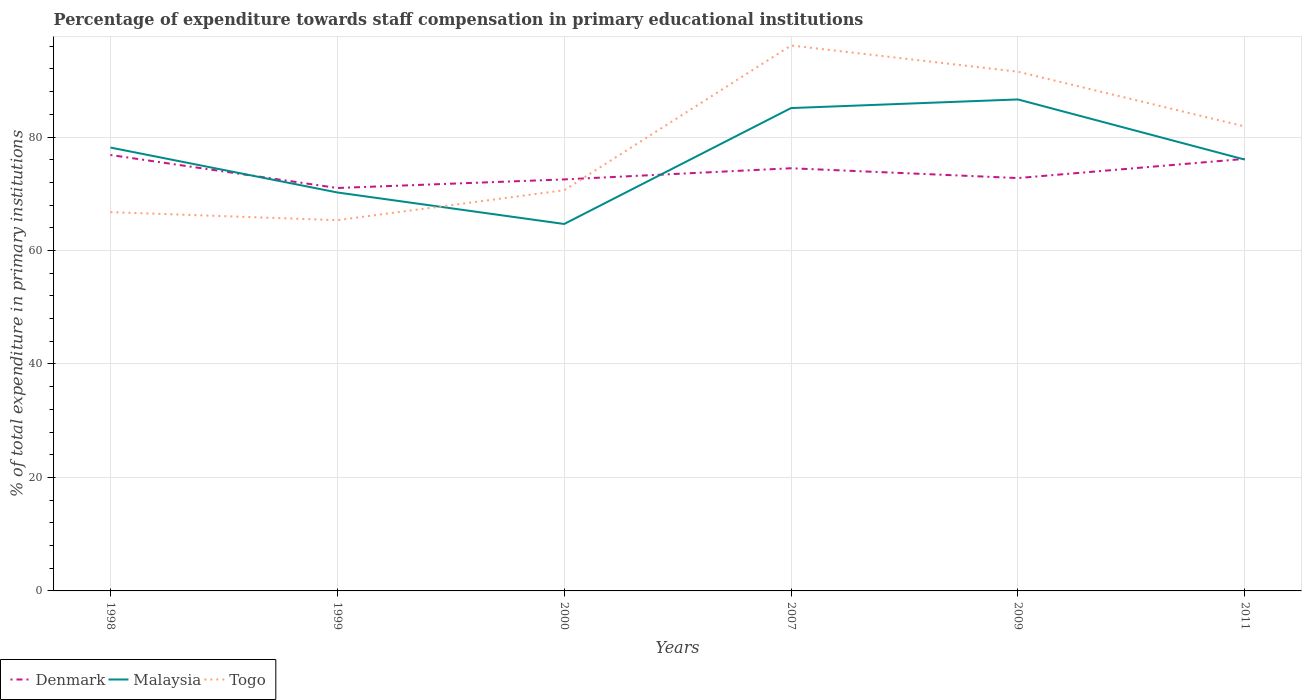How many different coloured lines are there?
Offer a very short reply. 3. Does the line corresponding to Denmark intersect with the line corresponding to Malaysia?
Make the answer very short. Yes. Is the number of lines equal to the number of legend labels?
Your answer should be very brief. Yes. Across all years, what is the maximum percentage of expenditure towards staff compensation in Denmark?
Offer a terse response. 71.01. In which year was the percentage of expenditure towards staff compensation in Denmark maximum?
Offer a very short reply. 1999. What is the total percentage of expenditure towards staff compensation in Togo in the graph?
Make the answer very short. 9.64. What is the difference between the highest and the second highest percentage of expenditure towards staff compensation in Malaysia?
Ensure brevity in your answer.  21.95. What is the difference between the highest and the lowest percentage of expenditure towards staff compensation in Denmark?
Provide a short and direct response. 3. Is the percentage of expenditure towards staff compensation in Togo strictly greater than the percentage of expenditure towards staff compensation in Denmark over the years?
Provide a short and direct response. No. What is the difference between two consecutive major ticks on the Y-axis?
Provide a succinct answer. 20. Does the graph contain any zero values?
Provide a short and direct response. No. Where does the legend appear in the graph?
Give a very brief answer. Bottom left. How are the legend labels stacked?
Your answer should be compact. Horizontal. What is the title of the graph?
Keep it short and to the point. Percentage of expenditure towards staff compensation in primary educational institutions. Does "Timor-Leste" appear as one of the legend labels in the graph?
Offer a terse response. No. What is the label or title of the X-axis?
Your answer should be compact. Years. What is the label or title of the Y-axis?
Ensure brevity in your answer.  % of total expenditure in primary institutions. What is the % of total expenditure in primary institutions in Denmark in 1998?
Your response must be concise. 76.83. What is the % of total expenditure in primary institutions of Malaysia in 1998?
Ensure brevity in your answer.  78.14. What is the % of total expenditure in primary institutions of Togo in 1998?
Provide a short and direct response. 66.76. What is the % of total expenditure in primary institutions of Denmark in 1999?
Provide a short and direct response. 71.01. What is the % of total expenditure in primary institutions in Malaysia in 1999?
Offer a very short reply. 70.23. What is the % of total expenditure in primary institutions in Togo in 1999?
Provide a succinct answer. 65.34. What is the % of total expenditure in primary institutions of Denmark in 2000?
Give a very brief answer. 72.53. What is the % of total expenditure in primary institutions of Malaysia in 2000?
Your answer should be very brief. 64.67. What is the % of total expenditure in primary institutions in Togo in 2000?
Give a very brief answer. 70.62. What is the % of total expenditure in primary institutions of Denmark in 2007?
Make the answer very short. 74.5. What is the % of total expenditure in primary institutions in Malaysia in 2007?
Your response must be concise. 85.1. What is the % of total expenditure in primary institutions of Togo in 2007?
Provide a short and direct response. 96.13. What is the % of total expenditure in primary institutions in Denmark in 2009?
Ensure brevity in your answer.  72.77. What is the % of total expenditure in primary institutions of Malaysia in 2009?
Keep it short and to the point. 86.62. What is the % of total expenditure in primary institutions of Togo in 2009?
Give a very brief answer. 91.51. What is the % of total expenditure in primary institutions in Denmark in 2011?
Give a very brief answer. 76.15. What is the % of total expenditure in primary institutions of Malaysia in 2011?
Keep it short and to the point. 76.02. What is the % of total expenditure in primary institutions of Togo in 2011?
Your answer should be very brief. 81.87. Across all years, what is the maximum % of total expenditure in primary institutions of Denmark?
Offer a very short reply. 76.83. Across all years, what is the maximum % of total expenditure in primary institutions of Malaysia?
Your response must be concise. 86.62. Across all years, what is the maximum % of total expenditure in primary institutions of Togo?
Provide a short and direct response. 96.13. Across all years, what is the minimum % of total expenditure in primary institutions in Denmark?
Offer a terse response. 71.01. Across all years, what is the minimum % of total expenditure in primary institutions in Malaysia?
Provide a succinct answer. 64.67. Across all years, what is the minimum % of total expenditure in primary institutions of Togo?
Provide a short and direct response. 65.34. What is the total % of total expenditure in primary institutions of Denmark in the graph?
Your response must be concise. 443.78. What is the total % of total expenditure in primary institutions in Malaysia in the graph?
Offer a very short reply. 460.79. What is the total % of total expenditure in primary institutions in Togo in the graph?
Your response must be concise. 472.23. What is the difference between the % of total expenditure in primary institutions in Denmark in 1998 and that in 1999?
Offer a very short reply. 5.82. What is the difference between the % of total expenditure in primary institutions of Malaysia in 1998 and that in 1999?
Ensure brevity in your answer.  7.92. What is the difference between the % of total expenditure in primary institutions of Togo in 1998 and that in 1999?
Provide a short and direct response. 1.42. What is the difference between the % of total expenditure in primary institutions in Denmark in 1998 and that in 2000?
Provide a succinct answer. 4.31. What is the difference between the % of total expenditure in primary institutions in Malaysia in 1998 and that in 2000?
Give a very brief answer. 13.47. What is the difference between the % of total expenditure in primary institutions of Togo in 1998 and that in 2000?
Offer a very short reply. -3.86. What is the difference between the % of total expenditure in primary institutions in Denmark in 1998 and that in 2007?
Your response must be concise. 2.34. What is the difference between the % of total expenditure in primary institutions in Malaysia in 1998 and that in 2007?
Your response must be concise. -6.96. What is the difference between the % of total expenditure in primary institutions of Togo in 1998 and that in 2007?
Give a very brief answer. -29.37. What is the difference between the % of total expenditure in primary institutions in Denmark in 1998 and that in 2009?
Your response must be concise. 4.07. What is the difference between the % of total expenditure in primary institutions in Malaysia in 1998 and that in 2009?
Provide a short and direct response. -8.48. What is the difference between the % of total expenditure in primary institutions in Togo in 1998 and that in 2009?
Provide a succinct answer. -24.75. What is the difference between the % of total expenditure in primary institutions of Denmark in 1998 and that in 2011?
Keep it short and to the point. 0.69. What is the difference between the % of total expenditure in primary institutions in Malaysia in 1998 and that in 2011?
Provide a short and direct response. 2.12. What is the difference between the % of total expenditure in primary institutions in Togo in 1998 and that in 2011?
Your answer should be compact. -15.1. What is the difference between the % of total expenditure in primary institutions in Denmark in 1999 and that in 2000?
Make the answer very short. -1.51. What is the difference between the % of total expenditure in primary institutions in Malaysia in 1999 and that in 2000?
Give a very brief answer. 5.56. What is the difference between the % of total expenditure in primary institutions in Togo in 1999 and that in 2000?
Offer a terse response. -5.28. What is the difference between the % of total expenditure in primary institutions of Denmark in 1999 and that in 2007?
Provide a short and direct response. -3.48. What is the difference between the % of total expenditure in primary institutions in Malaysia in 1999 and that in 2007?
Keep it short and to the point. -14.87. What is the difference between the % of total expenditure in primary institutions in Togo in 1999 and that in 2007?
Make the answer very short. -30.78. What is the difference between the % of total expenditure in primary institutions in Denmark in 1999 and that in 2009?
Provide a succinct answer. -1.75. What is the difference between the % of total expenditure in primary institutions of Malaysia in 1999 and that in 2009?
Keep it short and to the point. -16.4. What is the difference between the % of total expenditure in primary institutions in Togo in 1999 and that in 2009?
Your answer should be compact. -26.17. What is the difference between the % of total expenditure in primary institutions of Denmark in 1999 and that in 2011?
Your answer should be compact. -5.13. What is the difference between the % of total expenditure in primary institutions of Malaysia in 1999 and that in 2011?
Offer a very short reply. -5.79. What is the difference between the % of total expenditure in primary institutions of Togo in 1999 and that in 2011?
Give a very brief answer. -16.52. What is the difference between the % of total expenditure in primary institutions of Denmark in 2000 and that in 2007?
Your answer should be compact. -1.97. What is the difference between the % of total expenditure in primary institutions in Malaysia in 2000 and that in 2007?
Ensure brevity in your answer.  -20.43. What is the difference between the % of total expenditure in primary institutions of Togo in 2000 and that in 2007?
Provide a succinct answer. -25.51. What is the difference between the % of total expenditure in primary institutions in Denmark in 2000 and that in 2009?
Your response must be concise. -0.24. What is the difference between the % of total expenditure in primary institutions in Malaysia in 2000 and that in 2009?
Your answer should be very brief. -21.95. What is the difference between the % of total expenditure in primary institutions of Togo in 2000 and that in 2009?
Give a very brief answer. -20.89. What is the difference between the % of total expenditure in primary institutions of Denmark in 2000 and that in 2011?
Your answer should be compact. -3.62. What is the difference between the % of total expenditure in primary institutions of Malaysia in 2000 and that in 2011?
Offer a terse response. -11.35. What is the difference between the % of total expenditure in primary institutions in Togo in 2000 and that in 2011?
Your response must be concise. -11.24. What is the difference between the % of total expenditure in primary institutions of Denmark in 2007 and that in 2009?
Keep it short and to the point. 1.73. What is the difference between the % of total expenditure in primary institutions of Malaysia in 2007 and that in 2009?
Ensure brevity in your answer.  -1.52. What is the difference between the % of total expenditure in primary institutions of Togo in 2007 and that in 2009?
Give a very brief answer. 4.62. What is the difference between the % of total expenditure in primary institutions in Denmark in 2007 and that in 2011?
Your answer should be compact. -1.65. What is the difference between the % of total expenditure in primary institutions in Malaysia in 2007 and that in 2011?
Keep it short and to the point. 9.08. What is the difference between the % of total expenditure in primary institutions of Togo in 2007 and that in 2011?
Your response must be concise. 14.26. What is the difference between the % of total expenditure in primary institutions of Denmark in 2009 and that in 2011?
Keep it short and to the point. -3.38. What is the difference between the % of total expenditure in primary institutions in Malaysia in 2009 and that in 2011?
Offer a terse response. 10.6. What is the difference between the % of total expenditure in primary institutions in Togo in 2009 and that in 2011?
Provide a succinct answer. 9.64. What is the difference between the % of total expenditure in primary institutions in Denmark in 1998 and the % of total expenditure in primary institutions in Malaysia in 1999?
Provide a short and direct response. 6.6. What is the difference between the % of total expenditure in primary institutions of Denmark in 1998 and the % of total expenditure in primary institutions of Togo in 1999?
Give a very brief answer. 11.49. What is the difference between the % of total expenditure in primary institutions in Malaysia in 1998 and the % of total expenditure in primary institutions in Togo in 1999?
Your answer should be compact. 12.8. What is the difference between the % of total expenditure in primary institutions in Denmark in 1998 and the % of total expenditure in primary institutions in Malaysia in 2000?
Give a very brief answer. 12.16. What is the difference between the % of total expenditure in primary institutions in Denmark in 1998 and the % of total expenditure in primary institutions in Togo in 2000?
Make the answer very short. 6.21. What is the difference between the % of total expenditure in primary institutions of Malaysia in 1998 and the % of total expenditure in primary institutions of Togo in 2000?
Offer a very short reply. 7.52. What is the difference between the % of total expenditure in primary institutions in Denmark in 1998 and the % of total expenditure in primary institutions in Malaysia in 2007?
Offer a terse response. -8.27. What is the difference between the % of total expenditure in primary institutions in Denmark in 1998 and the % of total expenditure in primary institutions in Togo in 2007?
Your answer should be compact. -19.3. What is the difference between the % of total expenditure in primary institutions in Malaysia in 1998 and the % of total expenditure in primary institutions in Togo in 2007?
Make the answer very short. -17.99. What is the difference between the % of total expenditure in primary institutions of Denmark in 1998 and the % of total expenditure in primary institutions of Malaysia in 2009?
Give a very brief answer. -9.79. What is the difference between the % of total expenditure in primary institutions in Denmark in 1998 and the % of total expenditure in primary institutions in Togo in 2009?
Your answer should be very brief. -14.68. What is the difference between the % of total expenditure in primary institutions in Malaysia in 1998 and the % of total expenditure in primary institutions in Togo in 2009?
Offer a very short reply. -13.37. What is the difference between the % of total expenditure in primary institutions in Denmark in 1998 and the % of total expenditure in primary institutions in Malaysia in 2011?
Provide a short and direct response. 0.81. What is the difference between the % of total expenditure in primary institutions of Denmark in 1998 and the % of total expenditure in primary institutions of Togo in 2011?
Offer a terse response. -5.03. What is the difference between the % of total expenditure in primary institutions in Malaysia in 1998 and the % of total expenditure in primary institutions in Togo in 2011?
Ensure brevity in your answer.  -3.72. What is the difference between the % of total expenditure in primary institutions in Denmark in 1999 and the % of total expenditure in primary institutions in Malaysia in 2000?
Offer a terse response. 6.34. What is the difference between the % of total expenditure in primary institutions of Denmark in 1999 and the % of total expenditure in primary institutions of Togo in 2000?
Ensure brevity in your answer.  0.39. What is the difference between the % of total expenditure in primary institutions in Malaysia in 1999 and the % of total expenditure in primary institutions in Togo in 2000?
Provide a short and direct response. -0.39. What is the difference between the % of total expenditure in primary institutions in Denmark in 1999 and the % of total expenditure in primary institutions in Malaysia in 2007?
Ensure brevity in your answer.  -14.09. What is the difference between the % of total expenditure in primary institutions of Denmark in 1999 and the % of total expenditure in primary institutions of Togo in 2007?
Offer a very short reply. -25.12. What is the difference between the % of total expenditure in primary institutions of Malaysia in 1999 and the % of total expenditure in primary institutions of Togo in 2007?
Your response must be concise. -25.9. What is the difference between the % of total expenditure in primary institutions of Denmark in 1999 and the % of total expenditure in primary institutions of Malaysia in 2009?
Make the answer very short. -15.61. What is the difference between the % of total expenditure in primary institutions in Denmark in 1999 and the % of total expenditure in primary institutions in Togo in 2009?
Keep it short and to the point. -20.5. What is the difference between the % of total expenditure in primary institutions of Malaysia in 1999 and the % of total expenditure in primary institutions of Togo in 2009?
Give a very brief answer. -21.28. What is the difference between the % of total expenditure in primary institutions of Denmark in 1999 and the % of total expenditure in primary institutions of Malaysia in 2011?
Your answer should be compact. -5.01. What is the difference between the % of total expenditure in primary institutions in Denmark in 1999 and the % of total expenditure in primary institutions in Togo in 2011?
Keep it short and to the point. -10.85. What is the difference between the % of total expenditure in primary institutions of Malaysia in 1999 and the % of total expenditure in primary institutions of Togo in 2011?
Your answer should be very brief. -11.64. What is the difference between the % of total expenditure in primary institutions of Denmark in 2000 and the % of total expenditure in primary institutions of Malaysia in 2007?
Your response must be concise. -12.57. What is the difference between the % of total expenditure in primary institutions in Denmark in 2000 and the % of total expenditure in primary institutions in Togo in 2007?
Make the answer very short. -23.6. What is the difference between the % of total expenditure in primary institutions in Malaysia in 2000 and the % of total expenditure in primary institutions in Togo in 2007?
Your answer should be compact. -31.46. What is the difference between the % of total expenditure in primary institutions of Denmark in 2000 and the % of total expenditure in primary institutions of Malaysia in 2009?
Make the answer very short. -14.1. What is the difference between the % of total expenditure in primary institutions in Denmark in 2000 and the % of total expenditure in primary institutions in Togo in 2009?
Offer a terse response. -18.98. What is the difference between the % of total expenditure in primary institutions in Malaysia in 2000 and the % of total expenditure in primary institutions in Togo in 2009?
Make the answer very short. -26.84. What is the difference between the % of total expenditure in primary institutions of Denmark in 2000 and the % of total expenditure in primary institutions of Malaysia in 2011?
Ensure brevity in your answer.  -3.49. What is the difference between the % of total expenditure in primary institutions of Denmark in 2000 and the % of total expenditure in primary institutions of Togo in 2011?
Your answer should be very brief. -9.34. What is the difference between the % of total expenditure in primary institutions of Malaysia in 2000 and the % of total expenditure in primary institutions of Togo in 2011?
Offer a terse response. -17.19. What is the difference between the % of total expenditure in primary institutions of Denmark in 2007 and the % of total expenditure in primary institutions of Malaysia in 2009?
Your response must be concise. -12.13. What is the difference between the % of total expenditure in primary institutions of Denmark in 2007 and the % of total expenditure in primary institutions of Togo in 2009?
Offer a terse response. -17.01. What is the difference between the % of total expenditure in primary institutions in Malaysia in 2007 and the % of total expenditure in primary institutions in Togo in 2009?
Provide a succinct answer. -6.41. What is the difference between the % of total expenditure in primary institutions of Denmark in 2007 and the % of total expenditure in primary institutions of Malaysia in 2011?
Keep it short and to the point. -1.53. What is the difference between the % of total expenditure in primary institutions in Denmark in 2007 and the % of total expenditure in primary institutions in Togo in 2011?
Make the answer very short. -7.37. What is the difference between the % of total expenditure in primary institutions in Malaysia in 2007 and the % of total expenditure in primary institutions in Togo in 2011?
Ensure brevity in your answer.  3.24. What is the difference between the % of total expenditure in primary institutions of Denmark in 2009 and the % of total expenditure in primary institutions of Malaysia in 2011?
Make the answer very short. -3.25. What is the difference between the % of total expenditure in primary institutions of Denmark in 2009 and the % of total expenditure in primary institutions of Togo in 2011?
Your response must be concise. -9.1. What is the difference between the % of total expenditure in primary institutions in Malaysia in 2009 and the % of total expenditure in primary institutions in Togo in 2011?
Keep it short and to the point. 4.76. What is the average % of total expenditure in primary institutions of Denmark per year?
Make the answer very short. 73.96. What is the average % of total expenditure in primary institutions of Malaysia per year?
Make the answer very short. 76.8. What is the average % of total expenditure in primary institutions in Togo per year?
Ensure brevity in your answer.  78.71. In the year 1998, what is the difference between the % of total expenditure in primary institutions in Denmark and % of total expenditure in primary institutions in Malaysia?
Give a very brief answer. -1.31. In the year 1998, what is the difference between the % of total expenditure in primary institutions in Denmark and % of total expenditure in primary institutions in Togo?
Keep it short and to the point. 10.07. In the year 1998, what is the difference between the % of total expenditure in primary institutions of Malaysia and % of total expenditure in primary institutions of Togo?
Offer a terse response. 11.38. In the year 1999, what is the difference between the % of total expenditure in primary institutions in Denmark and % of total expenditure in primary institutions in Malaysia?
Provide a succinct answer. 0.79. In the year 1999, what is the difference between the % of total expenditure in primary institutions of Denmark and % of total expenditure in primary institutions of Togo?
Keep it short and to the point. 5.67. In the year 1999, what is the difference between the % of total expenditure in primary institutions of Malaysia and % of total expenditure in primary institutions of Togo?
Ensure brevity in your answer.  4.88. In the year 2000, what is the difference between the % of total expenditure in primary institutions in Denmark and % of total expenditure in primary institutions in Malaysia?
Your answer should be compact. 7.85. In the year 2000, what is the difference between the % of total expenditure in primary institutions of Denmark and % of total expenditure in primary institutions of Togo?
Provide a short and direct response. 1.91. In the year 2000, what is the difference between the % of total expenditure in primary institutions in Malaysia and % of total expenditure in primary institutions in Togo?
Your response must be concise. -5.95. In the year 2007, what is the difference between the % of total expenditure in primary institutions in Denmark and % of total expenditure in primary institutions in Malaysia?
Ensure brevity in your answer.  -10.61. In the year 2007, what is the difference between the % of total expenditure in primary institutions in Denmark and % of total expenditure in primary institutions in Togo?
Your response must be concise. -21.63. In the year 2007, what is the difference between the % of total expenditure in primary institutions of Malaysia and % of total expenditure in primary institutions of Togo?
Your answer should be very brief. -11.03. In the year 2009, what is the difference between the % of total expenditure in primary institutions in Denmark and % of total expenditure in primary institutions in Malaysia?
Give a very brief answer. -13.86. In the year 2009, what is the difference between the % of total expenditure in primary institutions of Denmark and % of total expenditure in primary institutions of Togo?
Offer a terse response. -18.74. In the year 2009, what is the difference between the % of total expenditure in primary institutions in Malaysia and % of total expenditure in primary institutions in Togo?
Ensure brevity in your answer.  -4.89. In the year 2011, what is the difference between the % of total expenditure in primary institutions in Denmark and % of total expenditure in primary institutions in Malaysia?
Provide a succinct answer. 0.12. In the year 2011, what is the difference between the % of total expenditure in primary institutions in Denmark and % of total expenditure in primary institutions in Togo?
Offer a very short reply. -5.72. In the year 2011, what is the difference between the % of total expenditure in primary institutions of Malaysia and % of total expenditure in primary institutions of Togo?
Ensure brevity in your answer.  -5.84. What is the ratio of the % of total expenditure in primary institutions of Denmark in 1998 to that in 1999?
Your response must be concise. 1.08. What is the ratio of the % of total expenditure in primary institutions in Malaysia in 1998 to that in 1999?
Provide a short and direct response. 1.11. What is the ratio of the % of total expenditure in primary institutions in Togo in 1998 to that in 1999?
Your response must be concise. 1.02. What is the ratio of the % of total expenditure in primary institutions in Denmark in 1998 to that in 2000?
Provide a short and direct response. 1.06. What is the ratio of the % of total expenditure in primary institutions in Malaysia in 1998 to that in 2000?
Keep it short and to the point. 1.21. What is the ratio of the % of total expenditure in primary institutions of Togo in 1998 to that in 2000?
Provide a succinct answer. 0.95. What is the ratio of the % of total expenditure in primary institutions of Denmark in 1998 to that in 2007?
Your response must be concise. 1.03. What is the ratio of the % of total expenditure in primary institutions in Malaysia in 1998 to that in 2007?
Provide a short and direct response. 0.92. What is the ratio of the % of total expenditure in primary institutions in Togo in 1998 to that in 2007?
Make the answer very short. 0.69. What is the ratio of the % of total expenditure in primary institutions of Denmark in 1998 to that in 2009?
Offer a terse response. 1.06. What is the ratio of the % of total expenditure in primary institutions of Malaysia in 1998 to that in 2009?
Keep it short and to the point. 0.9. What is the ratio of the % of total expenditure in primary institutions in Togo in 1998 to that in 2009?
Provide a short and direct response. 0.73. What is the ratio of the % of total expenditure in primary institutions in Denmark in 1998 to that in 2011?
Offer a very short reply. 1.01. What is the ratio of the % of total expenditure in primary institutions in Malaysia in 1998 to that in 2011?
Offer a very short reply. 1.03. What is the ratio of the % of total expenditure in primary institutions in Togo in 1998 to that in 2011?
Make the answer very short. 0.82. What is the ratio of the % of total expenditure in primary institutions of Denmark in 1999 to that in 2000?
Offer a terse response. 0.98. What is the ratio of the % of total expenditure in primary institutions in Malaysia in 1999 to that in 2000?
Your answer should be very brief. 1.09. What is the ratio of the % of total expenditure in primary institutions in Togo in 1999 to that in 2000?
Provide a succinct answer. 0.93. What is the ratio of the % of total expenditure in primary institutions of Denmark in 1999 to that in 2007?
Ensure brevity in your answer.  0.95. What is the ratio of the % of total expenditure in primary institutions in Malaysia in 1999 to that in 2007?
Offer a terse response. 0.83. What is the ratio of the % of total expenditure in primary institutions in Togo in 1999 to that in 2007?
Your answer should be very brief. 0.68. What is the ratio of the % of total expenditure in primary institutions in Denmark in 1999 to that in 2009?
Keep it short and to the point. 0.98. What is the ratio of the % of total expenditure in primary institutions of Malaysia in 1999 to that in 2009?
Provide a short and direct response. 0.81. What is the ratio of the % of total expenditure in primary institutions of Togo in 1999 to that in 2009?
Your answer should be compact. 0.71. What is the ratio of the % of total expenditure in primary institutions in Denmark in 1999 to that in 2011?
Make the answer very short. 0.93. What is the ratio of the % of total expenditure in primary institutions of Malaysia in 1999 to that in 2011?
Ensure brevity in your answer.  0.92. What is the ratio of the % of total expenditure in primary institutions in Togo in 1999 to that in 2011?
Keep it short and to the point. 0.8. What is the ratio of the % of total expenditure in primary institutions of Denmark in 2000 to that in 2007?
Give a very brief answer. 0.97. What is the ratio of the % of total expenditure in primary institutions in Malaysia in 2000 to that in 2007?
Provide a succinct answer. 0.76. What is the ratio of the % of total expenditure in primary institutions of Togo in 2000 to that in 2007?
Offer a very short reply. 0.73. What is the ratio of the % of total expenditure in primary institutions in Denmark in 2000 to that in 2009?
Your response must be concise. 1. What is the ratio of the % of total expenditure in primary institutions in Malaysia in 2000 to that in 2009?
Make the answer very short. 0.75. What is the ratio of the % of total expenditure in primary institutions in Togo in 2000 to that in 2009?
Offer a terse response. 0.77. What is the ratio of the % of total expenditure in primary institutions in Denmark in 2000 to that in 2011?
Make the answer very short. 0.95. What is the ratio of the % of total expenditure in primary institutions in Malaysia in 2000 to that in 2011?
Offer a terse response. 0.85. What is the ratio of the % of total expenditure in primary institutions in Togo in 2000 to that in 2011?
Keep it short and to the point. 0.86. What is the ratio of the % of total expenditure in primary institutions in Denmark in 2007 to that in 2009?
Keep it short and to the point. 1.02. What is the ratio of the % of total expenditure in primary institutions in Malaysia in 2007 to that in 2009?
Keep it short and to the point. 0.98. What is the ratio of the % of total expenditure in primary institutions in Togo in 2007 to that in 2009?
Your answer should be very brief. 1.05. What is the ratio of the % of total expenditure in primary institutions of Denmark in 2007 to that in 2011?
Make the answer very short. 0.98. What is the ratio of the % of total expenditure in primary institutions in Malaysia in 2007 to that in 2011?
Your answer should be compact. 1.12. What is the ratio of the % of total expenditure in primary institutions of Togo in 2007 to that in 2011?
Provide a succinct answer. 1.17. What is the ratio of the % of total expenditure in primary institutions of Denmark in 2009 to that in 2011?
Your response must be concise. 0.96. What is the ratio of the % of total expenditure in primary institutions of Malaysia in 2009 to that in 2011?
Your answer should be very brief. 1.14. What is the ratio of the % of total expenditure in primary institutions of Togo in 2009 to that in 2011?
Your answer should be compact. 1.12. What is the difference between the highest and the second highest % of total expenditure in primary institutions of Denmark?
Offer a very short reply. 0.69. What is the difference between the highest and the second highest % of total expenditure in primary institutions in Malaysia?
Give a very brief answer. 1.52. What is the difference between the highest and the second highest % of total expenditure in primary institutions in Togo?
Offer a terse response. 4.62. What is the difference between the highest and the lowest % of total expenditure in primary institutions of Denmark?
Keep it short and to the point. 5.82. What is the difference between the highest and the lowest % of total expenditure in primary institutions of Malaysia?
Your answer should be very brief. 21.95. What is the difference between the highest and the lowest % of total expenditure in primary institutions in Togo?
Your answer should be very brief. 30.78. 